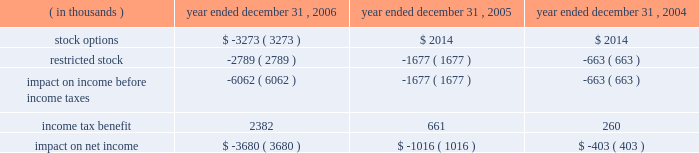Packaging corporation of america notes to consolidated financial statements ( continued ) december 31 , 2006 4 .
Stock-based compensation ( continued ) same period was $ 1988000 lower , than if it had continued to account for share-based compensation under apb no .
25 .
Basic and diluted earnings per share for the year ended december 31 , 2006 were both $ 0.02 lower than if the company had continued to account for share-based compensation under apb no .
25 .
Prior to the adoption of sfas no .
123 ( r ) , the company presented all tax benefits of deductions resulting from share-based payment arrangements as operating cash flows in the statements of cash flows .
Sfas no .
123 ( r ) requires the cash flows resulting from the tax benefits from tax deductions in excess of the compensation cost recognized for those share awards ( excess tax benefits ) to be classified as financing cash flows .
The excess tax benefit of $ 2885000 classified as a financing cash inflow for the year ended december 31 , 2006 would have been classified as an operating cash inflow if the company had not adopted sfas no .
123 ( r ) .
As a result of adopting sfas no 123 ( r ) , unearned compensation previously recorded in stockholders 2019 equity was reclassified against additional paid in capital on january 1 , 2006 .
All stock-based compensation expense not recognized as of december 31 , 2005 and compensation expense related to post 2005 grants of stock options and amortization of restricted stock will be recorded directly to additional paid in capital .
Compensation expense for stock options and restricted stock recognized in the statements of income for the year ended december 31 , 2006 , 2005 and 2004 was as follows : year ended december 31 , ( in thousands ) 2006 2005 2004 .

For 2006 , was stock options expense greater than restricted stock expense? 
Computations: (3273 > 2789)
Answer: yes. 